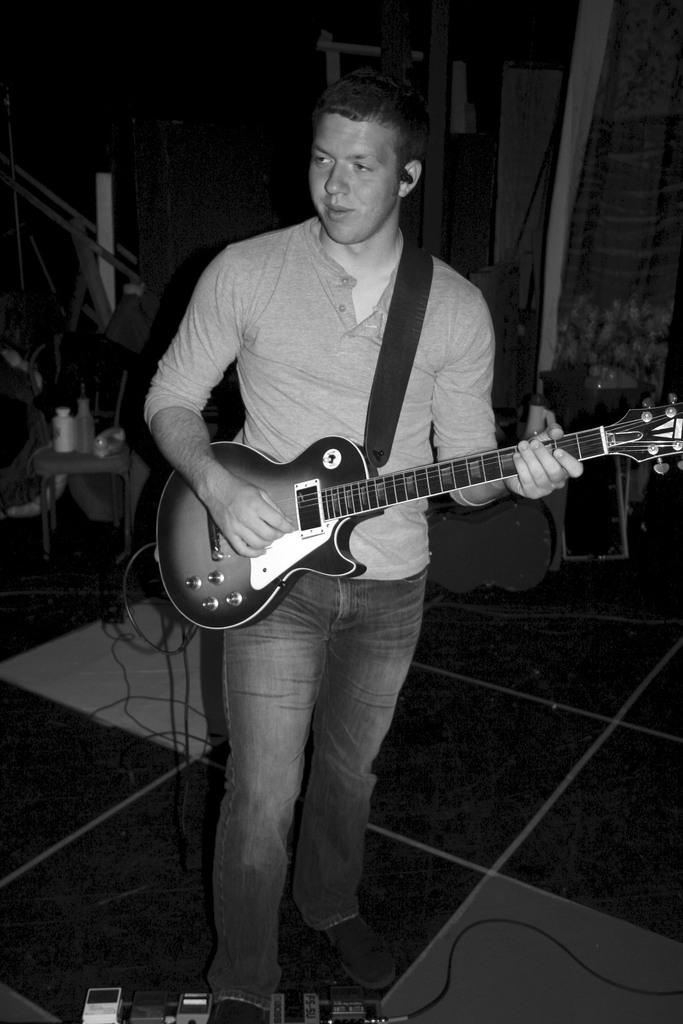What is the main subject of the image? There is a man in the image. What is the man doing in the image? The man is standing and playing the guitar. How is the guitar being used in the image? The guitar is in the man's hands. What can be seen in the background of the image? There are background elements in the image, including a curtain. How many parcels can be seen in the image? There are no parcels present in the image. What is the rate of increase in the man's guitar playing skills in the image? The image does not provide information about the man's guitar playing skills or any increase in them. 